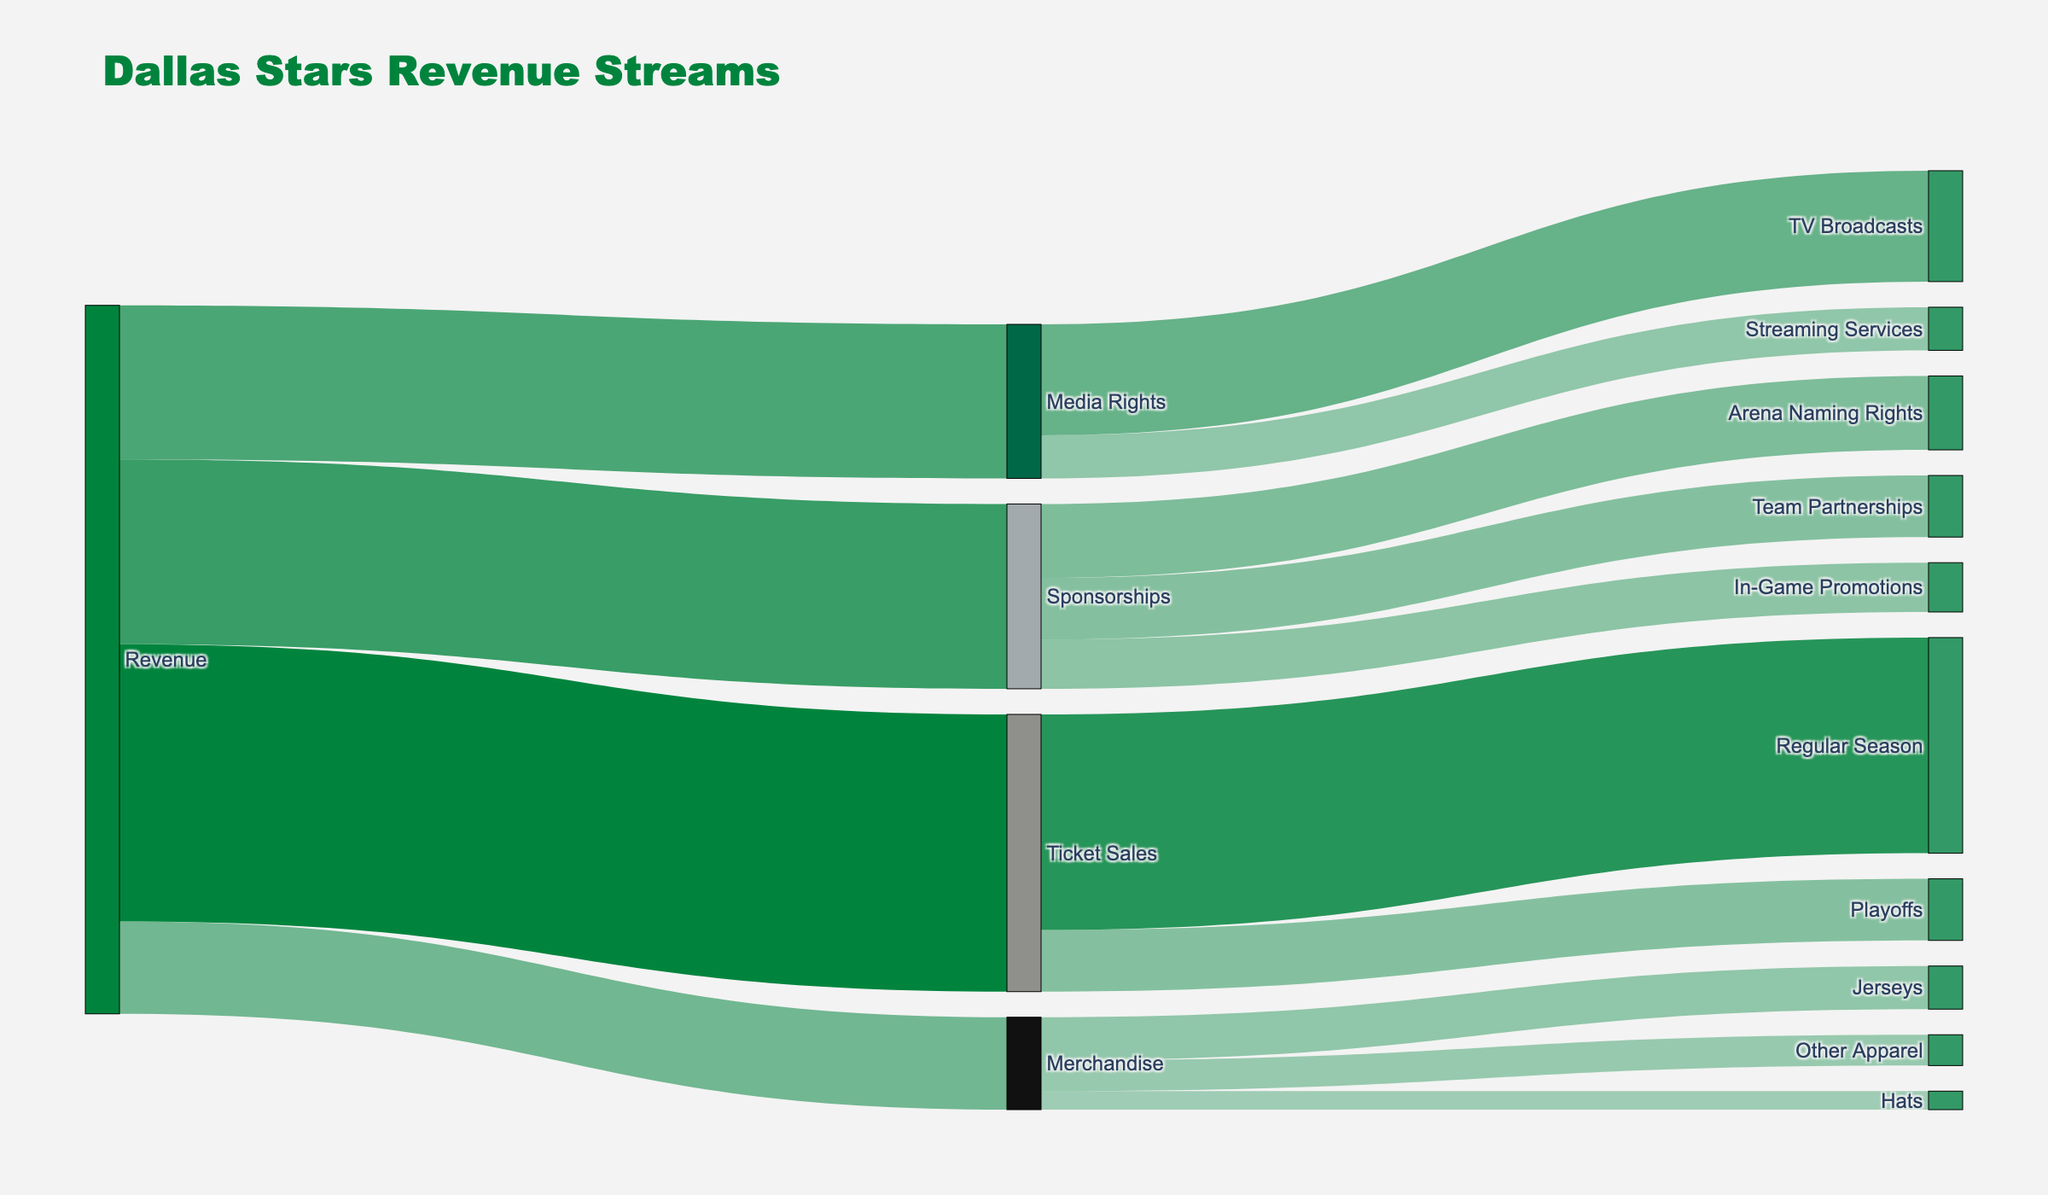What is the title of the Sankey diagram? The title is located at the top of the diagram and informs the viewer about the main subject of the representation, which is the revenue streams for the Dallas Stars organization.
Answer: Dallas Stars Revenue Streams How much revenue does the "Regular Season" contribute to Ticket Sales? Follow the flow from "Ticket Sales" to "Regular Season," noting the value shown next to the link.
Answer: $35,000,000 How much revenue is generated by Media Rights in total? Locate the source flow labeled "Media Rights" and sum the values corresponding to all its target flows. The values are for "TV Broadcasts" and "Streaming Services."
Answer: $25,000,000 Which is the least significant revenue source for Merchandise, and how much does it contribute? Identify the flows from "Merchandise" to each of its targets, and find the one with the smallest value.
Answer: Hats, $3,000,000 What is the combined revenue from Sponsorships and Media Rights together? Find the total revenues from "Sponsorships" and "Media Rights" individually and add them together.
Answer: $30,000,000 (Sponsorships) + $25,000,000 (Media Rights) = $55,000,000 How does the revenue from "Arena Naming Rights" compare to "In-Game Promotions" under Sponsorships? Compare the values of the flows from "Sponsorships" to "Arena Naming Rights" and "In-Game Promotions."
Answer: Arena Naming Rights generates $12,000,000, which is more than In-Game Promotions at $8,000,000 What percentage of the total revenue comes from Ticket Sales? Compute the total revenue first, then calculate the percentage that comes from Ticket Sales by dividing the value of the Ticket Sales by the total revenue and multiplying by 100. Total revenue is the sum of all categories.
Answer: 45,000,000 / (45,000,000 + 15,000,000 + 30,000,000 + 25,000,000) x 100 = 45% Which individual revenue stream under "Sponsorships" has the highest value? Identify the streams under "Sponsorships" and compare their values to determine the highest.
Answer: Arena Naming Rights How much more revenue does "TV Broadcasts" generate compared to "Streaming Services"? Subtract the value of "Streaming Services" from the value of "TV Broadcasts."
Answer: $18,000,000 - $7,000,000 = $11,000,000 What is the total revenue from all sources of the organization? Sum all the values flowing into the main "Revenue" node. These are the values directly linked to "Revenue."
Answer: $115,000,000 